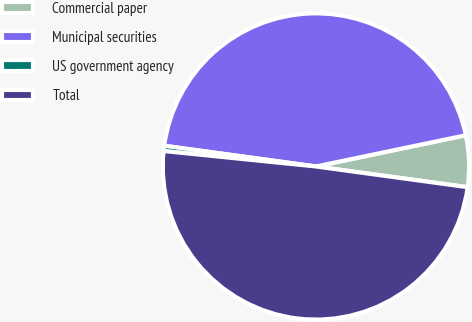<chart> <loc_0><loc_0><loc_500><loc_500><pie_chart><fcel>Commercial paper<fcel>Municipal securities<fcel>US government agency<fcel>Total<nl><fcel>5.43%<fcel>44.57%<fcel>0.55%<fcel>49.45%<nl></chart> 